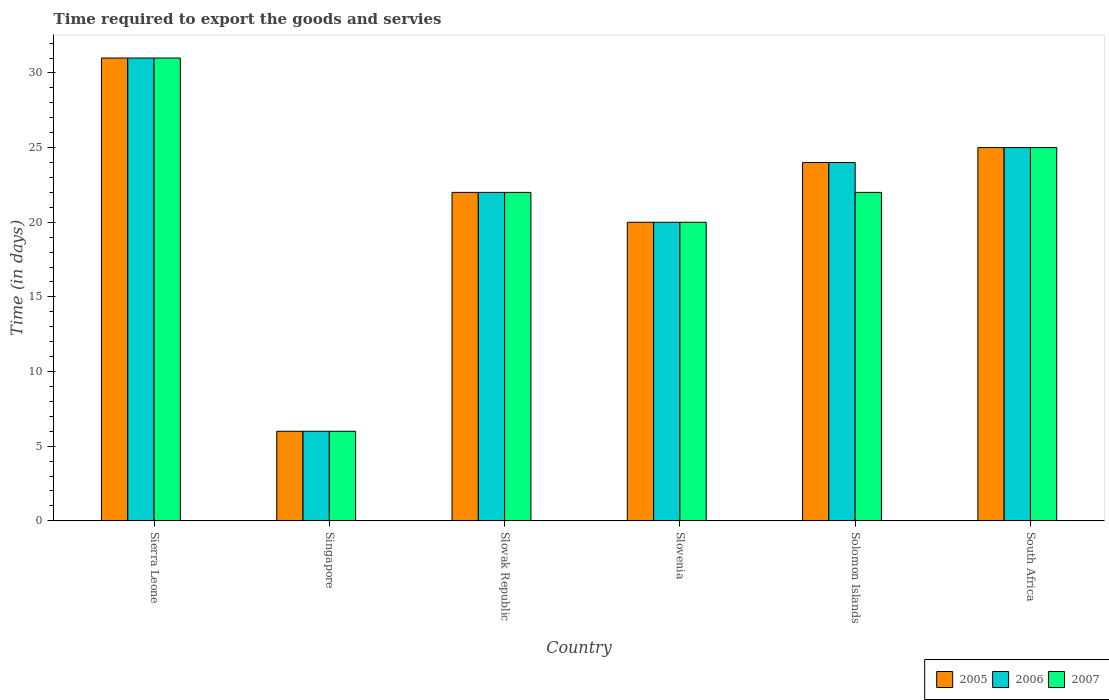How many different coloured bars are there?
Keep it short and to the point. 3. Are the number of bars per tick equal to the number of legend labels?
Your answer should be very brief. Yes. How many bars are there on the 5th tick from the right?
Your response must be concise. 3. What is the label of the 1st group of bars from the left?
Your answer should be compact. Sierra Leone. In how many cases, is the number of bars for a given country not equal to the number of legend labels?
Your answer should be compact. 0. What is the number of days required to export the goods and services in 2006 in Slovak Republic?
Provide a short and direct response. 22. Across all countries, what is the maximum number of days required to export the goods and services in 2006?
Give a very brief answer. 31. Across all countries, what is the minimum number of days required to export the goods and services in 2005?
Keep it short and to the point. 6. In which country was the number of days required to export the goods and services in 2007 maximum?
Ensure brevity in your answer.  Sierra Leone. In which country was the number of days required to export the goods and services in 2007 minimum?
Give a very brief answer. Singapore. What is the total number of days required to export the goods and services in 2007 in the graph?
Make the answer very short. 126. What is the difference between the number of days required to export the goods and services in 2005 in Singapore and the number of days required to export the goods and services in 2006 in Solomon Islands?
Ensure brevity in your answer.  -18. What is the difference between the number of days required to export the goods and services of/in 2005 and number of days required to export the goods and services of/in 2006 in Slovenia?
Provide a succinct answer. 0. In how many countries, is the number of days required to export the goods and services in 2006 greater than 12 days?
Provide a succinct answer. 5. What is the difference between the highest and the lowest number of days required to export the goods and services in 2007?
Your answer should be compact. 25. Is it the case that in every country, the sum of the number of days required to export the goods and services in 2007 and number of days required to export the goods and services in 2006 is greater than the number of days required to export the goods and services in 2005?
Your answer should be compact. Yes. How many countries are there in the graph?
Make the answer very short. 6. Are the values on the major ticks of Y-axis written in scientific E-notation?
Your answer should be compact. No. Where does the legend appear in the graph?
Provide a succinct answer. Bottom right. How are the legend labels stacked?
Your response must be concise. Horizontal. What is the title of the graph?
Provide a short and direct response. Time required to export the goods and servies. Does "1973" appear as one of the legend labels in the graph?
Keep it short and to the point. No. What is the label or title of the X-axis?
Keep it short and to the point. Country. What is the label or title of the Y-axis?
Provide a short and direct response. Time (in days). What is the Time (in days) of 2007 in Sierra Leone?
Provide a short and direct response. 31. What is the Time (in days) in 2006 in Singapore?
Offer a very short reply. 6. What is the Time (in days) in 2007 in Singapore?
Provide a short and direct response. 6. What is the Time (in days) of 2006 in Slovak Republic?
Your response must be concise. 22. What is the Time (in days) of 2007 in Slovenia?
Make the answer very short. 20. What is the Time (in days) in 2006 in Solomon Islands?
Make the answer very short. 24. What is the Time (in days) in 2007 in Solomon Islands?
Provide a short and direct response. 22. What is the Time (in days) of 2006 in South Africa?
Give a very brief answer. 25. Across all countries, what is the maximum Time (in days) in 2005?
Offer a very short reply. 31. Across all countries, what is the maximum Time (in days) in 2007?
Keep it short and to the point. 31. Across all countries, what is the minimum Time (in days) of 2007?
Offer a very short reply. 6. What is the total Time (in days) in 2005 in the graph?
Make the answer very short. 128. What is the total Time (in days) in 2006 in the graph?
Provide a short and direct response. 128. What is the total Time (in days) in 2007 in the graph?
Offer a very short reply. 126. What is the difference between the Time (in days) in 2005 in Sierra Leone and that in Singapore?
Ensure brevity in your answer.  25. What is the difference between the Time (in days) of 2006 in Sierra Leone and that in Slovak Republic?
Your response must be concise. 9. What is the difference between the Time (in days) in 2007 in Sierra Leone and that in Solomon Islands?
Offer a very short reply. 9. What is the difference between the Time (in days) of 2005 in Sierra Leone and that in South Africa?
Your answer should be very brief. 6. What is the difference between the Time (in days) in 2007 in Sierra Leone and that in South Africa?
Your answer should be compact. 6. What is the difference between the Time (in days) in 2007 in Singapore and that in Slovak Republic?
Your response must be concise. -16. What is the difference between the Time (in days) of 2007 in Singapore and that in Slovenia?
Keep it short and to the point. -14. What is the difference between the Time (in days) in 2005 in Singapore and that in Solomon Islands?
Provide a short and direct response. -18. What is the difference between the Time (in days) of 2006 in Singapore and that in Solomon Islands?
Your answer should be compact. -18. What is the difference between the Time (in days) of 2007 in Singapore and that in Solomon Islands?
Offer a very short reply. -16. What is the difference between the Time (in days) of 2006 in Singapore and that in South Africa?
Make the answer very short. -19. What is the difference between the Time (in days) in 2005 in Slovak Republic and that in Slovenia?
Provide a short and direct response. 2. What is the difference between the Time (in days) of 2007 in Slovak Republic and that in Slovenia?
Keep it short and to the point. 2. What is the difference between the Time (in days) of 2006 in Slovak Republic and that in Solomon Islands?
Ensure brevity in your answer.  -2. What is the difference between the Time (in days) in 2007 in Slovak Republic and that in South Africa?
Offer a terse response. -3. What is the difference between the Time (in days) in 2006 in Slovenia and that in Solomon Islands?
Give a very brief answer. -4. What is the difference between the Time (in days) of 2007 in Solomon Islands and that in South Africa?
Offer a terse response. -3. What is the difference between the Time (in days) in 2006 in Sierra Leone and the Time (in days) in 2007 in Singapore?
Make the answer very short. 25. What is the difference between the Time (in days) in 2006 in Sierra Leone and the Time (in days) in 2007 in Slovak Republic?
Your answer should be very brief. 9. What is the difference between the Time (in days) of 2005 in Sierra Leone and the Time (in days) of 2006 in Slovenia?
Provide a succinct answer. 11. What is the difference between the Time (in days) of 2006 in Sierra Leone and the Time (in days) of 2007 in Slovenia?
Make the answer very short. 11. What is the difference between the Time (in days) of 2005 in Sierra Leone and the Time (in days) of 2006 in Solomon Islands?
Give a very brief answer. 7. What is the difference between the Time (in days) in 2005 in Sierra Leone and the Time (in days) in 2007 in South Africa?
Keep it short and to the point. 6. What is the difference between the Time (in days) of 2005 in Singapore and the Time (in days) of 2007 in Slovak Republic?
Give a very brief answer. -16. What is the difference between the Time (in days) in 2005 in Singapore and the Time (in days) in 2006 in Slovenia?
Provide a succinct answer. -14. What is the difference between the Time (in days) in 2005 in Singapore and the Time (in days) in 2007 in Slovenia?
Make the answer very short. -14. What is the difference between the Time (in days) of 2005 in Singapore and the Time (in days) of 2007 in Solomon Islands?
Give a very brief answer. -16. What is the difference between the Time (in days) in 2005 in Slovak Republic and the Time (in days) in 2006 in Slovenia?
Offer a terse response. 2. What is the difference between the Time (in days) of 2006 in Slovak Republic and the Time (in days) of 2007 in Slovenia?
Provide a short and direct response. 2. What is the difference between the Time (in days) in 2005 in Slovak Republic and the Time (in days) in 2006 in Solomon Islands?
Your answer should be compact. -2. What is the difference between the Time (in days) in 2006 in Slovak Republic and the Time (in days) in 2007 in Solomon Islands?
Keep it short and to the point. 0. What is the difference between the Time (in days) in 2005 in Slovak Republic and the Time (in days) in 2006 in South Africa?
Give a very brief answer. -3. What is the difference between the Time (in days) of 2005 in Slovak Republic and the Time (in days) of 2007 in South Africa?
Your answer should be compact. -3. What is the difference between the Time (in days) in 2006 in Slovak Republic and the Time (in days) in 2007 in South Africa?
Keep it short and to the point. -3. What is the difference between the Time (in days) of 2005 in Slovenia and the Time (in days) of 2006 in Solomon Islands?
Your answer should be very brief. -4. What is the difference between the Time (in days) in 2005 in Slovenia and the Time (in days) in 2006 in South Africa?
Offer a terse response. -5. What is the difference between the Time (in days) in 2005 in Slovenia and the Time (in days) in 2007 in South Africa?
Give a very brief answer. -5. What is the difference between the Time (in days) of 2006 in Slovenia and the Time (in days) of 2007 in South Africa?
Keep it short and to the point. -5. What is the difference between the Time (in days) in 2005 in Solomon Islands and the Time (in days) in 2006 in South Africa?
Make the answer very short. -1. What is the difference between the Time (in days) in 2005 in Solomon Islands and the Time (in days) in 2007 in South Africa?
Your response must be concise. -1. What is the average Time (in days) in 2005 per country?
Keep it short and to the point. 21.33. What is the average Time (in days) in 2006 per country?
Keep it short and to the point. 21.33. What is the difference between the Time (in days) in 2005 and Time (in days) in 2006 in Sierra Leone?
Your response must be concise. 0. What is the difference between the Time (in days) of 2006 and Time (in days) of 2007 in Sierra Leone?
Provide a short and direct response. 0. What is the difference between the Time (in days) in 2006 and Time (in days) in 2007 in Slovak Republic?
Your response must be concise. 0. What is the difference between the Time (in days) in 2005 and Time (in days) in 2007 in Slovenia?
Provide a short and direct response. 0. What is the difference between the Time (in days) in 2006 and Time (in days) in 2007 in Slovenia?
Your answer should be very brief. 0. What is the difference between the Time (in days) of 2005 and Time (in days) of 2006 in South Africa?
Give a very brief answer. 0. What is the difference between the Time (in days) in 2005 and Time (in days) in 2007 in South Africa?
Make the answer very short. 0. What is the ratio of the Time (in days) of 2005 in Sierra Leone to that in Singapore?
Make the answer very short. 5.17. What is the ratio of the Time (in days) of 2006 in Sierra Leone to that in Singapore?
Offer a very short reply. 5.17. What is the ratio of the Time (in days) of 2007 in Sierra Leone to that in Singapore?
Offer a very short reply. 5.17. What is the ratio of the Time (in days) in 2005 in Sierra Leone to that in Slovak Republic?
Offer a terse response. 1.41. What is the ratio of the Time (in days) of 2006 in Sierra Leone to that in Slovak Republic?
Ensure brevity in your answer.  1.41. What is the ratio of the Time (in days) of 2007 in Sierra Leone to that in Slovak Republic?
Your response must be concise. 1.41. What is the ratio of the Time (in days) of 2005 in Sierra Leone to that in Slovenia?
Keep it short and to the point. 1.55. What is the ratio of the Time (in days) of 2006 in Sierra Leone to that in Slovenia?
Your response must be concise. 1.55. What is the ratio of the Time (in days) in 2007 in Sierra Leone to that in Slovenia?
Your answer should be very brief. 1.55. What is the ratio of the Time (in days) of 2005 in Sierra Leone to that in Solomon Islands?
Provide a short and direct response. 1.29. What is the ratio of the Time (in days) of 2006 in Sierra Leone to that in Solomon Islands?
Provide a succinct answer. 1.29. What is the ratio of the Time (in days) of 2007 in Sierra Leone to that in Solomon Islands?
Keep it short and to the point. 1.41. What is the ratio of the Time (in days) in 2005 in Sierra Leone to that in South Africa?
Your answer should be compact. 1.24. What is the ratio of the Time (in days) in 2006 in Sierra Leone to that in South Africa?
Make the answer very short. 1.24. What is the ratio of the Time (in days) of 2007 in Sierra Leone to that in South Africa?
Your answer should be compact. 1.24. What is the ratio of the Time (in days) of 2005 in Singapore to that in Slovak Republic?
Provide a short and direct response. 0.27. What is the ratio of the Time (in days) in 2006 in Singapore to that in Slovak Republic?
Your answer should be compact. 0.27. What is the ratio of the Time (in days) in 2007 in Singapore to that in Slovak Republic?
Keep it short and to the point. 0.27. What is the ratio of the Time (in days) in 2005 in Singapore to that in Slovenia?
Your response must be concise. 0.3. What is the ratio of the Time (in days) in 2006 in Singapore to that in Slovenia?
Ensure brevity in your answer.  0.3. What is the ratio of the Time (in days) in 2006 in Singapore to that in Solomon Islands?
Your response must be concise. 0.25. What is the ratio of the Time (in days) of 2007 in Singapore to that in Solomon Islands?
Ensure brevity in your answer.  0.27. What is the ratio of the Time (in days) of 2005 in Singapore to that in South Africa?
Offer a very short reply. 0.24. What is the ratio of the Time (in days) in 2006 in Singapore to that in South Africa?
Keep it short and to the point. 0.24. What is the ratio of the Time (in days) of 2007 in Singapore to that in South Africa?
Your answer should be very brief. 0.24. What is the ratio of the Time (in days) of 2006 in Slovak Republic to that in Slovenia?
Provide a short and direct response. 1.1. What is the ratio of the Time (in days) in 2006 in Slovak Republic to that in Solomon Islands?
Your answer should be very brief. 0.92. What is the ratio of the Time (in days) of 2006 in Slovak Republic to that in South Africa?
Offer a terse response. 0.88. What is the ratio of the Time (in days) of 2005 in Slovenia to that in South Africa?
Provide a short and direct response. 0.8. What is the ratio of the Time (in days) in 2006 in Slovenia to that in South Africa?
Offer a terse response. 0.8. What is the difference between the highest and the second highest Time (in days) of 2006?
Offer a very short reply. 6. What is the difference between the highest and the lowest Time (in days) in 2005?
Give a very brief answer. 25. What is the difference between the highest and the lowest Time (in days) in 2006?
Make the answer very short. 25. What is the difference between the highest and the lowest Time (in days) in 2007?
Provide a short and direct response. 25. 